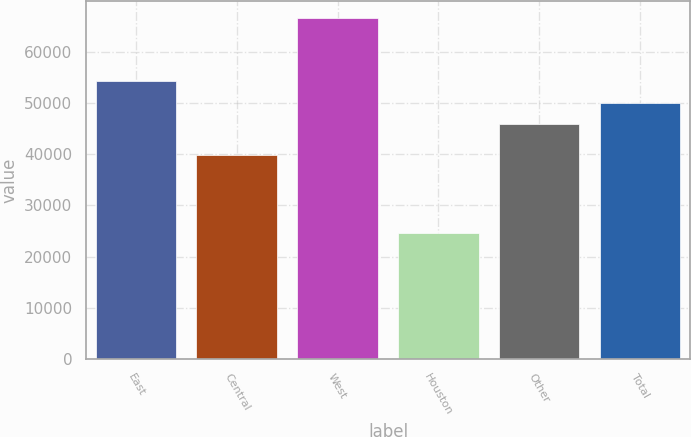Convert chart to OTSL. <chart><loc_0><loc_0><loc_500><loc_500><bar_chart><fcel>East<fcel>Central<fcel>West<fcel>Houston<fcel>Other<fcel>Total<nl><fcel>54300<fcel>39800<fcel>66600<fcel>24600<fcel>45900<fcel>50100<nl></chart> 